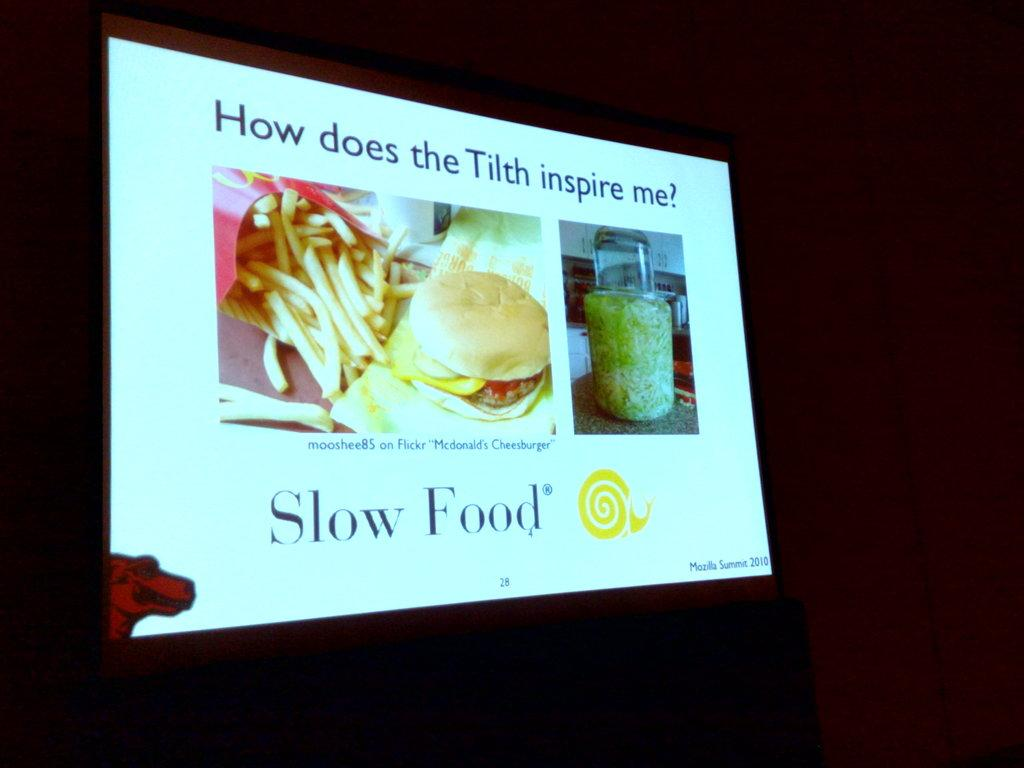What is located in the foreground of the image? There is a screen in the foreground of the image. What can be seen in the background of the image? The background of the image is dark. What type of leaf can be seen on the screen in the image? There is no leaf present on the screen in the image. How many fingers are visible on the screen in the image? There is no indication of fingers on the screen in the image. 